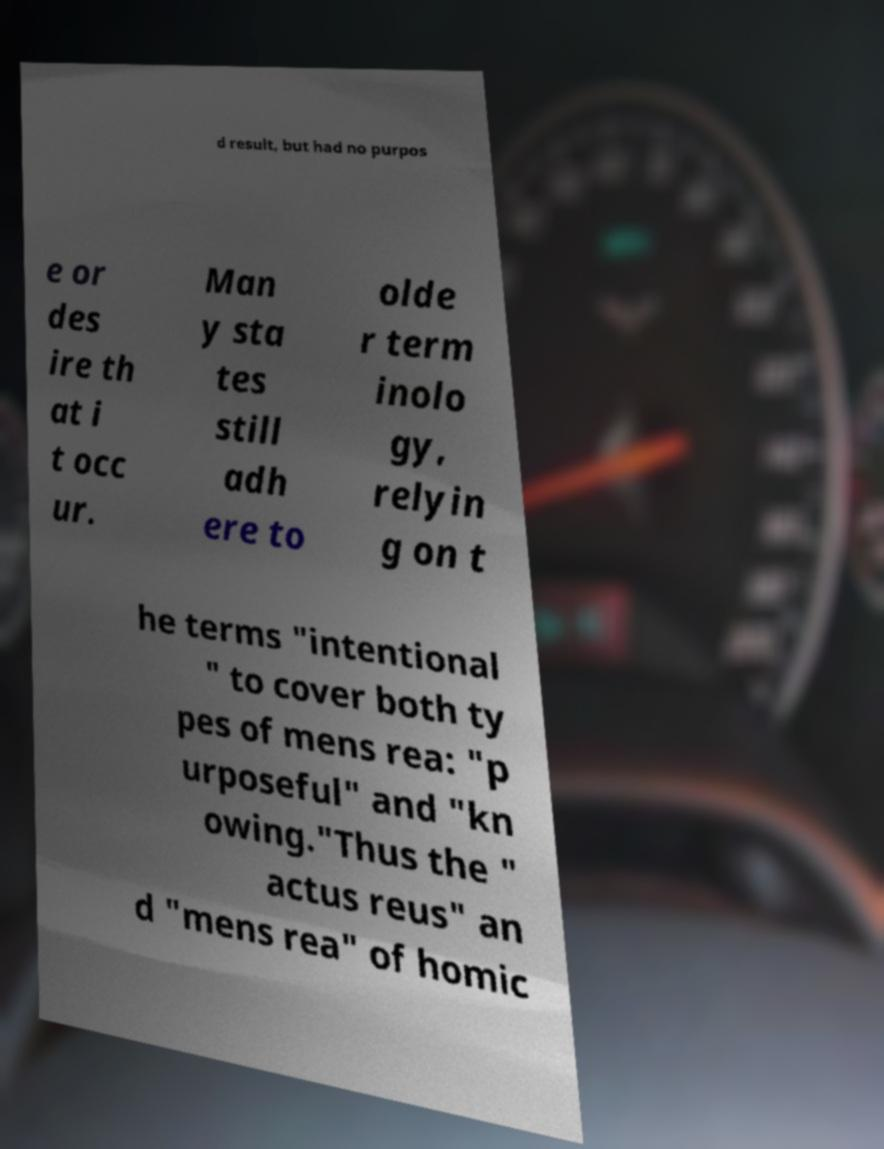There's text embedded in this image that I need extracted. Can you transcribe it verbatim? d result, but had no purpos e or des ire th at i t occ ur. Man y sta tes still adh ere to olde r term inolo gy, relyin g on t he terms "intentional " to cover both ty pes of mens rea: "p urposeful" and "kn owing."Thus the " actus reus" an d "mens rea" of homic 